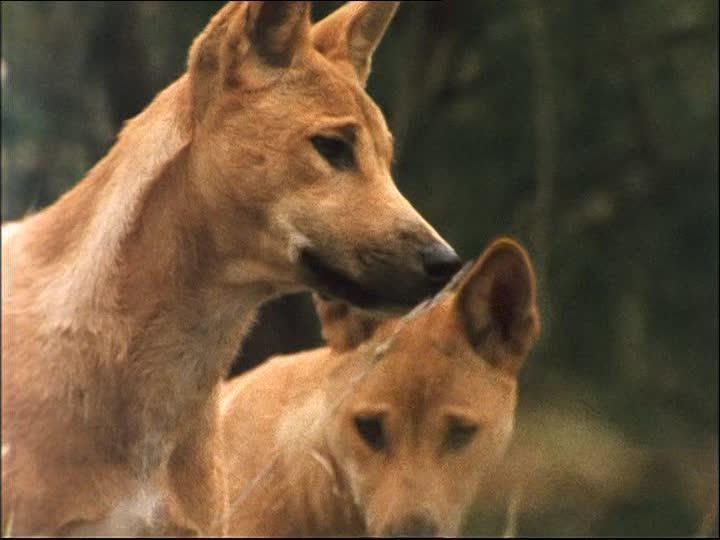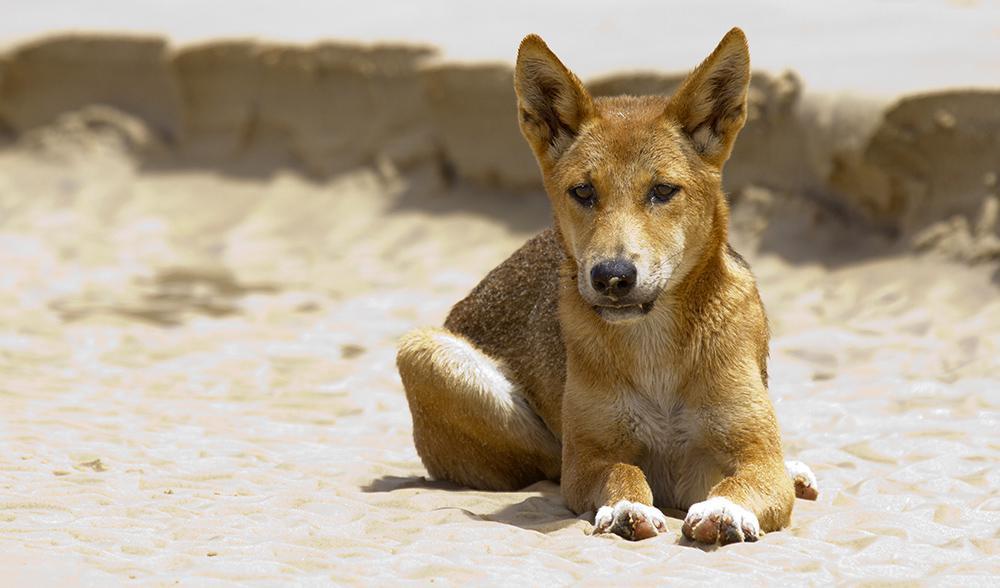The first image is the image on the left, the second image is the image on the right. Given the left and right images, does the statement "There are three dogs" hold true? Answer yes or no. Yes. 